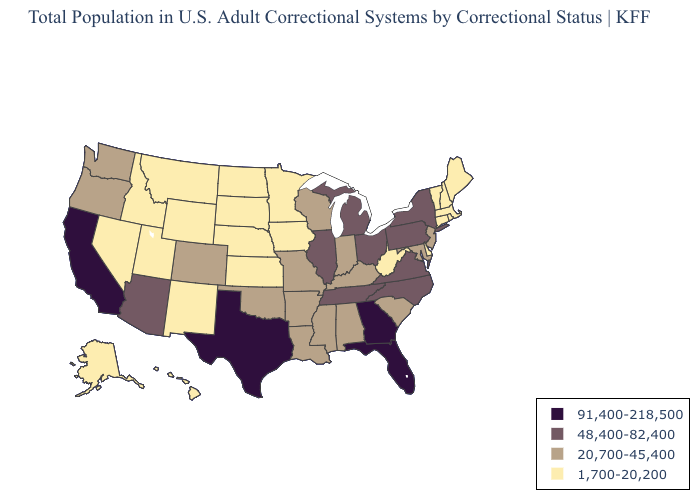Which states have the lowest value in the USA?
Short answer required. Alaska, Connecticut, Delaware, Hawaii, Idaho, Iowa, Kansas, Maine, Massachusetts, Minnesota, Montana, Nebraska, Nevada, New Hampshire, New Mexico, North Dakota, Rhode Island, South Dakota, Utah, Vermont, West Virginia, Wyoming. Which states have the lowest value in the USA?
Concise answer only. Alaska, Connecticut, Delaware, Hawaii, Idaho, Iowa, Kansas, Maine, Massachusetts, Minnesota, Montana, Nebraska, Nevada, New Hampshire, New Mexico, North Dakota, Rhode Island, South Dakota, Utah, Vermont, West Virginia, Wyoming. Name the states that have a value in the range 20,700-45,400?
Short answer required. Alabama, Arkansas, Colorado, Indiana, Kentucky, Louisiana, Maryland, Mississippi, Missouri, New Jersey, Oklahoma, Oregon, South Carolina, Washington, Wisconsin. Name the states that have a value in the range 48,400-82,400?
Keep it brief. Arizona, Illinois, Michigan, New York, North Carolina, Ohio, Pennsylvania, Tennessee, Virginia. Does Indiana have the lowest value in the USA?
Give a very brief answer. No. What is the lowest value in the USA?
Be succinct. 1,700-20,200. Among the states that border South Dakota , which have the lowest value?
Keep it brief. Iowa, Minnesota, Montana, Nebraska, North Dakota, Wyoming. Does the first symbol in the legend represent the smallest category?
Write a very short answer. No. Among the states that border New Jersey , which have the lowest value?
Be succinct. Delaware. Which states have the lowest value in the USA?
Answer briefly. Alaska, Connecticut, Delaware, Hawaii, Idaho, Iowa, Kansas, Maine, Massachusetts, Minnesota, Montana, Nebraska, Nevada, New Hampshire, New Mexico, North Dakota, Rhode Island, South Dakota, Utah, Vermont, West Virginia, Wyoming. Name the states that have a value in the range 48,400-82,400?
Quick response, please. Arizona, Illinois, Michigan, New York, North Carolina, Ohio, Pennsylvania, Tennessee, Virginia. What is the value of Massachusetts?
Answer briefly. 1,700-20,200. What is the value of South Carolina?
Keep it brief. 20,700-45,400. Does Florida have the highest value in the USA?
Be succinct. Yes. 